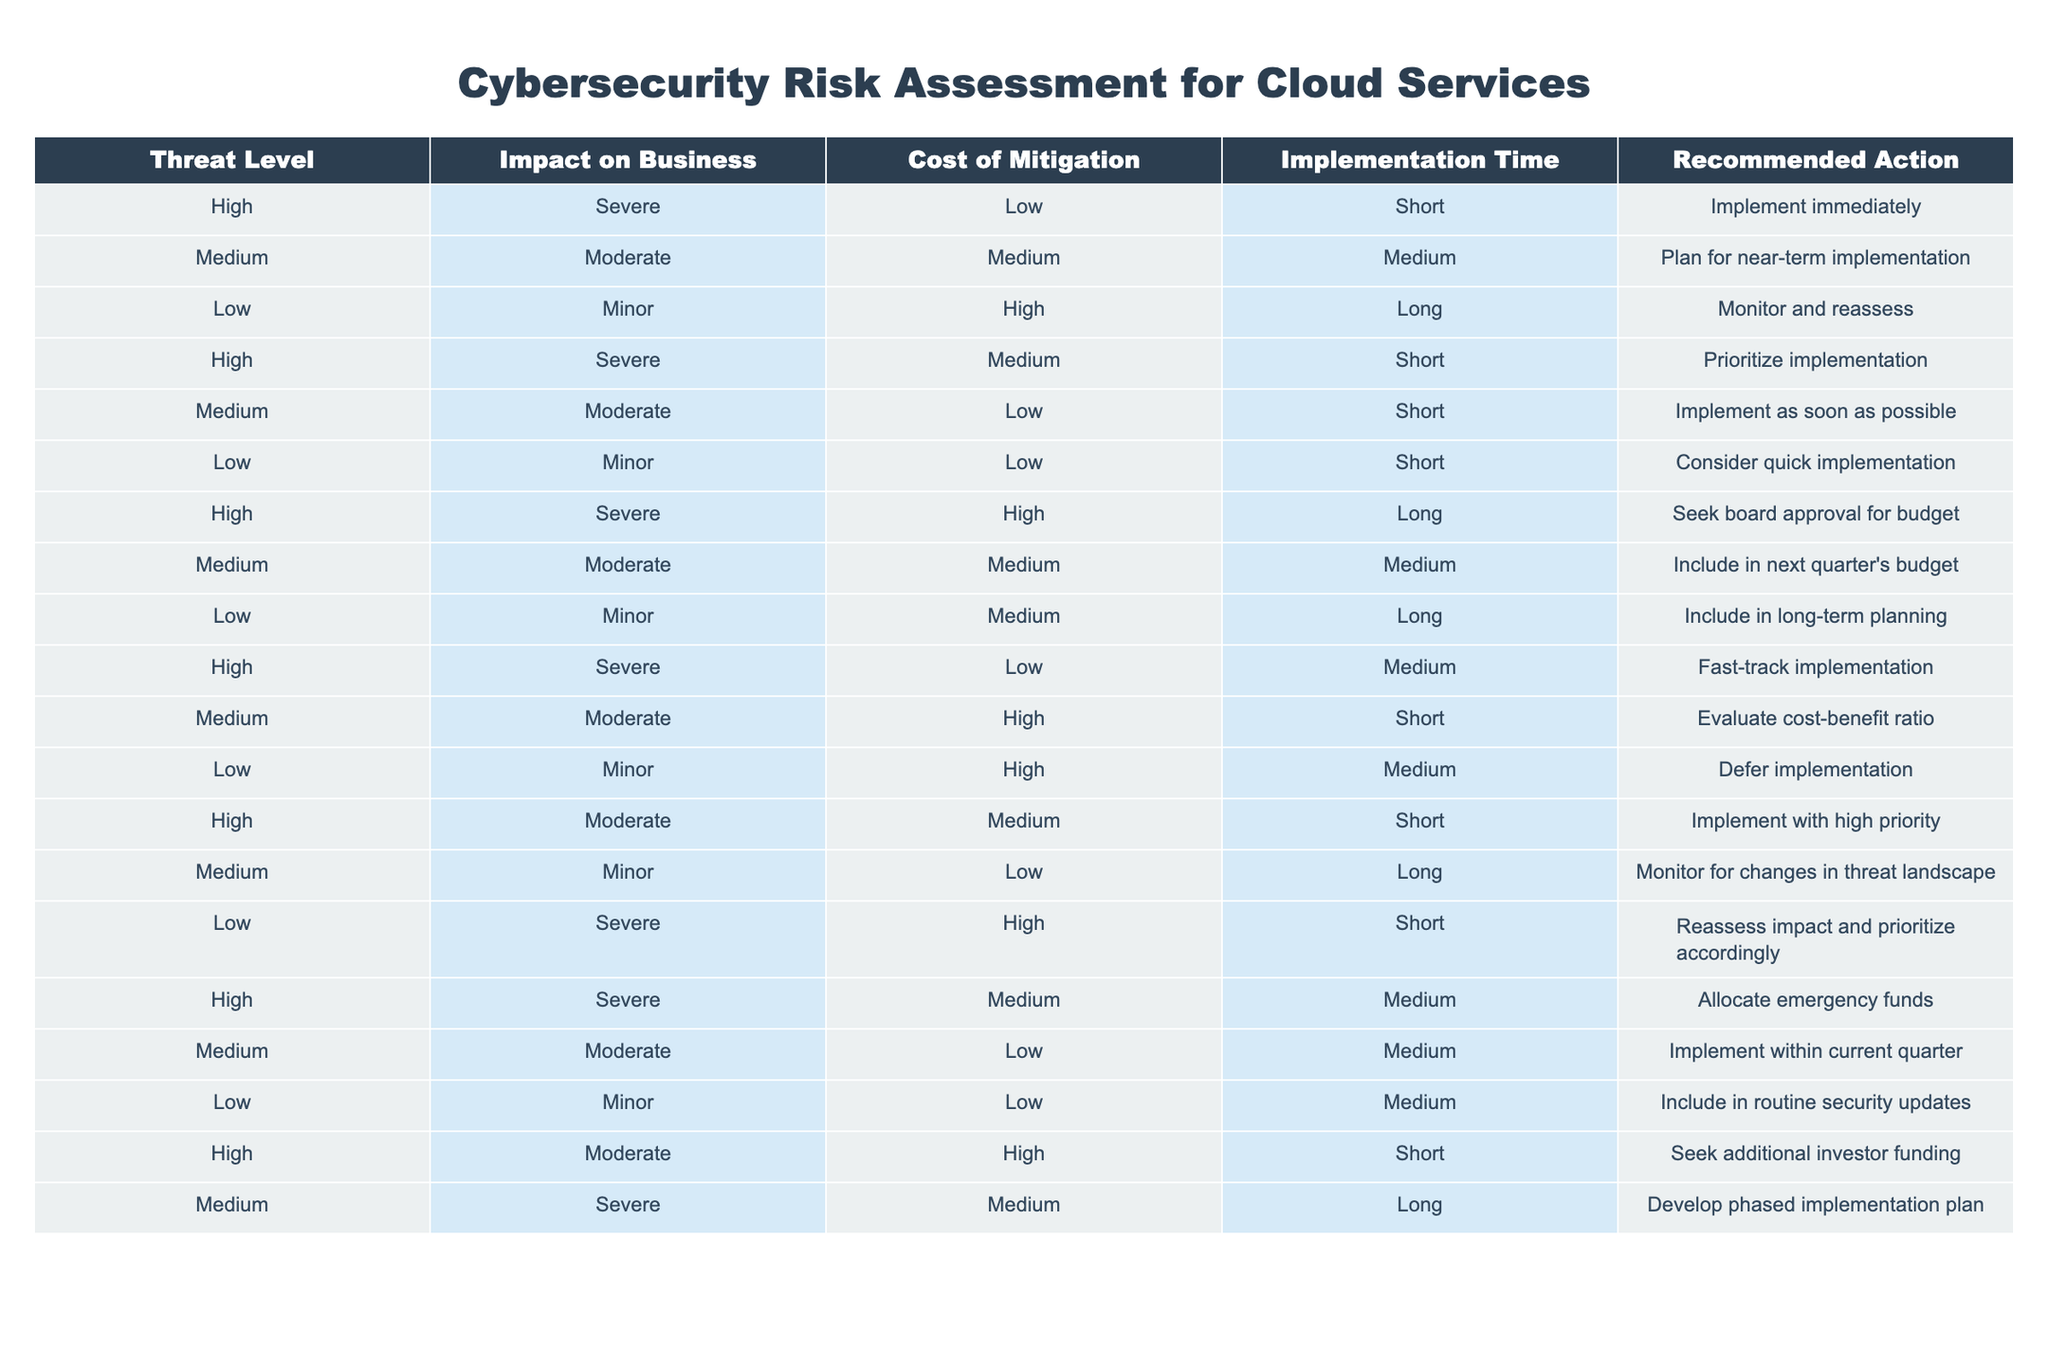What is the recommended action for a cybersecurity threat with a high threat level and low cost of mitigation? According to the table, the recommended action for a high threat level with low cost of mitigation is to "Implement immediately." This can be found directly under the relevant row for high threat level and low cost of mitigation.
Answer: Implement immediately How many different recommended actions are there for threats classified as high? The table lists five instances where the threat level is high. Each instance has a unique recommended action, resulting in a total of five recommended actions for high threat levels.
Answer: 5 Is the impact on business for all low-threat levels classified as minor? Yes, according to the table, all entries under low threat levels show "Minor" as the impact on business. This means that low-threat levels consistently have a minor impact.
Answer: Yes What is the average cost of mitigation for medium threat level entries? The medium threat level has three different cost values: Medium (2 occurrences) and Low (1 occurrence). To find the average, we assign a numerical value (Medium=2, Low=1) and calculate the average as follows: (2+2+1)/3 = 5/3 = 1.67 or Medium. Since cost levels are categorized, the cost of mitigation for medium threat levels is mostly Medium.
Answer: Medium What action should be prioritized for a high threat that requires emergency funds and has a severe impact? The recommended action listed for a high threat with a severe impact and a medium cost of mitigation is to "Allocate emergency funds." This points out the importance of acting swiftly in response to high severity threats requiring immediate funding.
Answer: Allocate emergency funds What is the cost of mitigation for the medium threat level that should be implemented within the current quarter? The relevant entry reveals that the cost of mitigation for the medium threat level that should be implemented within the current quarter is categorized as Low. This can be identified specifically from that row in the table.
Answer: Low Are there any low-threat levels that recommend fast-tracking implementation? No, in the table, there are no entries for low threat levels that recommend fast-tracking implementation. All recommendations for low threats are either monitoring or other actions.
Answer: No Which recommended action appears more frequently for high threat levels: 'Implement immediately' or 'Prioritize implementation'? The table shows that 'Implement immediately' appears once and 'Prioritize implementation' also appears once, so they both occur with the same frequency which is once each for high threat levels.
Answer: Equal frequency What is the implementation time for the medium threat level that includes in the next quarter's budget? The implementation time for the medium threat level that includes the action in the next quarter's budget is listed as Long in the corresponding row of the table.
Answer: Long 